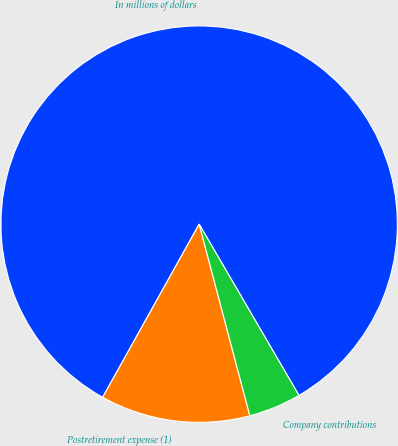Convert chart. <chart><loc_0><loc_0><loc_500><loc_500><pie_chart><fcel>In millions of dollars<fcel>Postretirement expense (1)<fcel>Company contributions<nl><fcel>83.51%<fcel>12.21%<fcel>4.28%<nl></chart> 